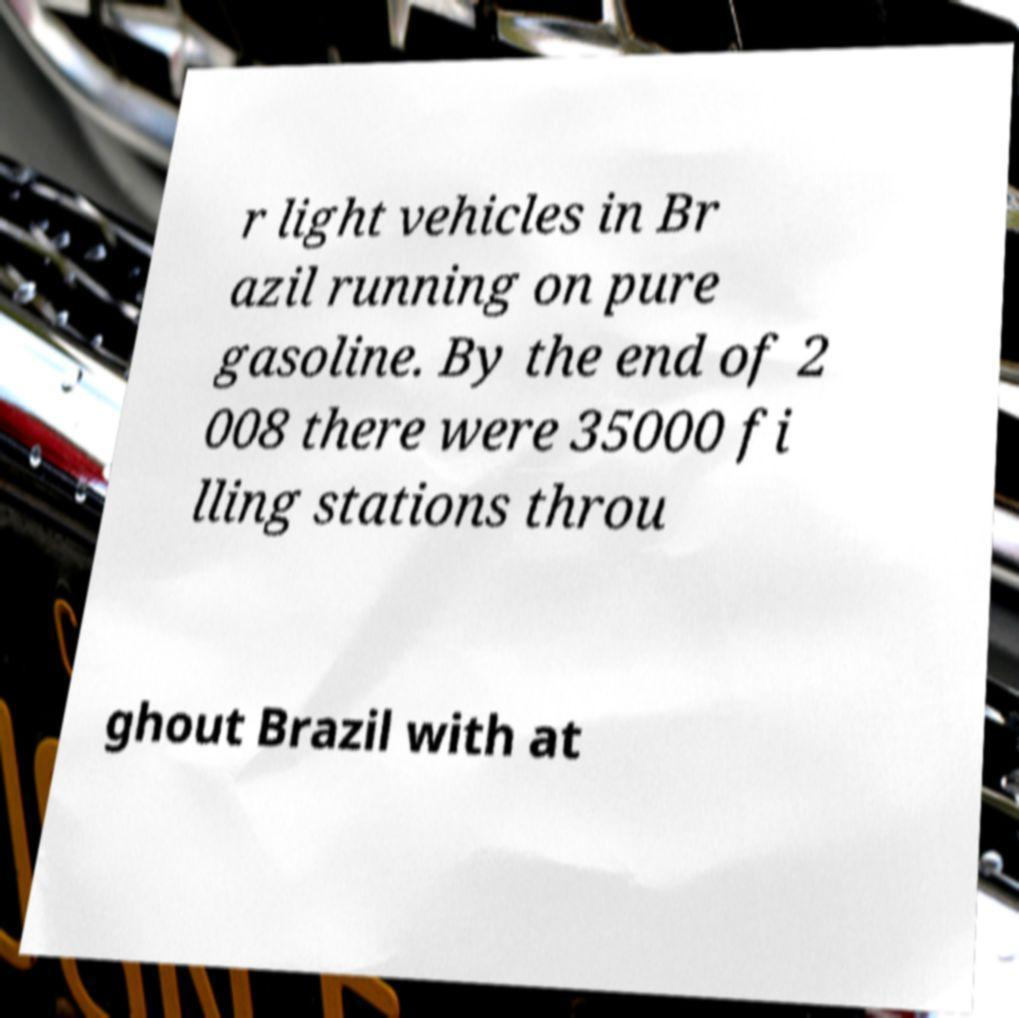I need the written content from this picture converted into text. Can you do that? r light vehicles in Br azil running on pure gasoline. By the end of 2 008 there were 35000 fi lling stations throu ghout Brazil with at 